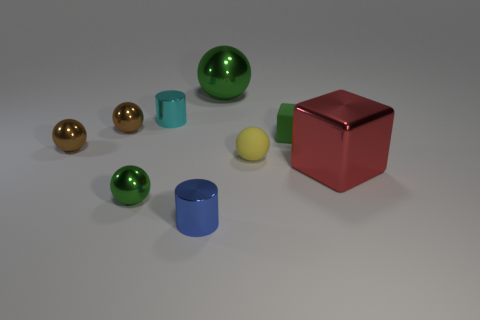There is a matte object that is the same color as the large ball; what shape is it?
Your response must be concise. Cube. What size is the cube that is the same color as the big sphere?
Make the answer very short. Small. What number of other objects are the same shape as the small cyan thing?
Ensure brevity in your answer.  1. What is the color of the small shiny thing that is on the right side of the small green sphere and behind the blue metallic cylinder?
Your answer should be very brief. Cyan. Is there anything else that is the same size as the red shiny object?
Your answer should be compact. Yes. There is a small shiny cylinder behind the big red metallic object; is its color the same as the big metal ball?
Your response must be concise. No. What number of cylinders are either small blue metallic things or gray rubber objects?
Offer a terse response. 1. The large red metal thing that is right of the yellow thing has what shape?
Provide a short and direct response. Cube. There is a small matte cube that is to the right of the yellow object that is in front of the metal cylinder behind the blue metal object; what is its color?
Ensure brevity in your answer.  Green. Does the yellow thing have the same material as the green cube?
Offer a terse response. Yes. 